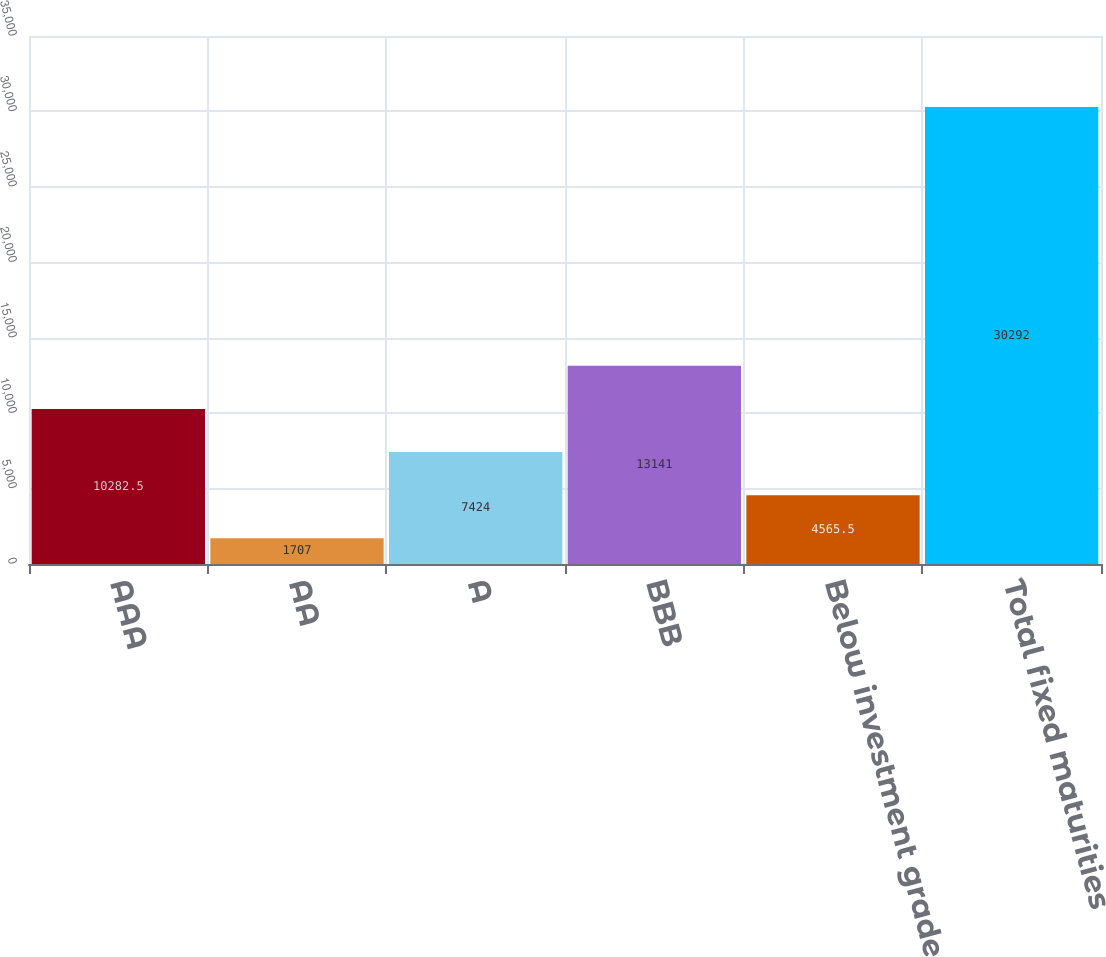Convert chart to OTSL. <chart><loc_0><loc_0><loc_500><loc_500><bar_chart><fcel>AAA<fcel>AA<fcel>A<fcel>BBB<fcel>Below investment grade<fcel>Total fixed maturities<nl><fcel>10282.5<fcel>1707<fcel>7424<fcel>13141<fcel>4565.5<fcel>30292<nl></chart> 